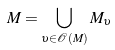<formula> <loc_0><loc_0><loc_500><loc_500>M = \bigcup _ { \upsilon \in \mathcal { O } ( M ) } M _ { \upsilon }</formula> 